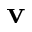Convert formula to latex. <formula><loc_0><loc_0><loc_500><loc_500>v</formula> 